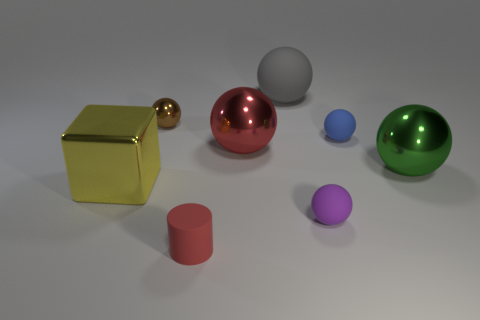Subtract all blue rubber spheres. How many spheres are left? 5 Add 1 tiny blue rubber things. How many objects exist? 9 Subtract all gray balls. How many balls are left? 5 Subtract all spheres. How many objects are left? 2 Add 6 small red matte cylinders. How many small red matte cylinders are left? 7 Add 6 small things. How many small things exist? 10 Subtract 1 green spheres. How many objects are left? 7 Subtract 1 cylinders. How many cylinders are left? 0 Subtract all yellow cylinders. Subtract all blue balls. How many cylinders are left? 1 Subtract all yellow blocks. How many red balls are left? 1 